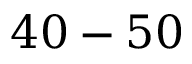<formula> <loc_0><loc_0><loc_500><loc_500>4 0 - 5 0 \</formula> 